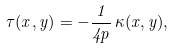Convert formula to latex. <formula><loc_0><loc_0><loc_500><loc_500>\tau ( x , y ) = - \frac { 1 } { 4 p } \, \kappa ( x , y ) ,</formula> 